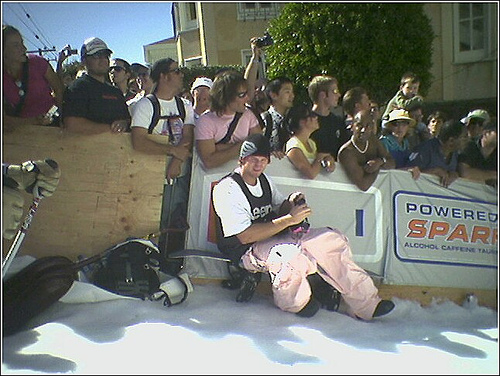Please extract the text content from this image. ALCOHCA SPAR ED een 